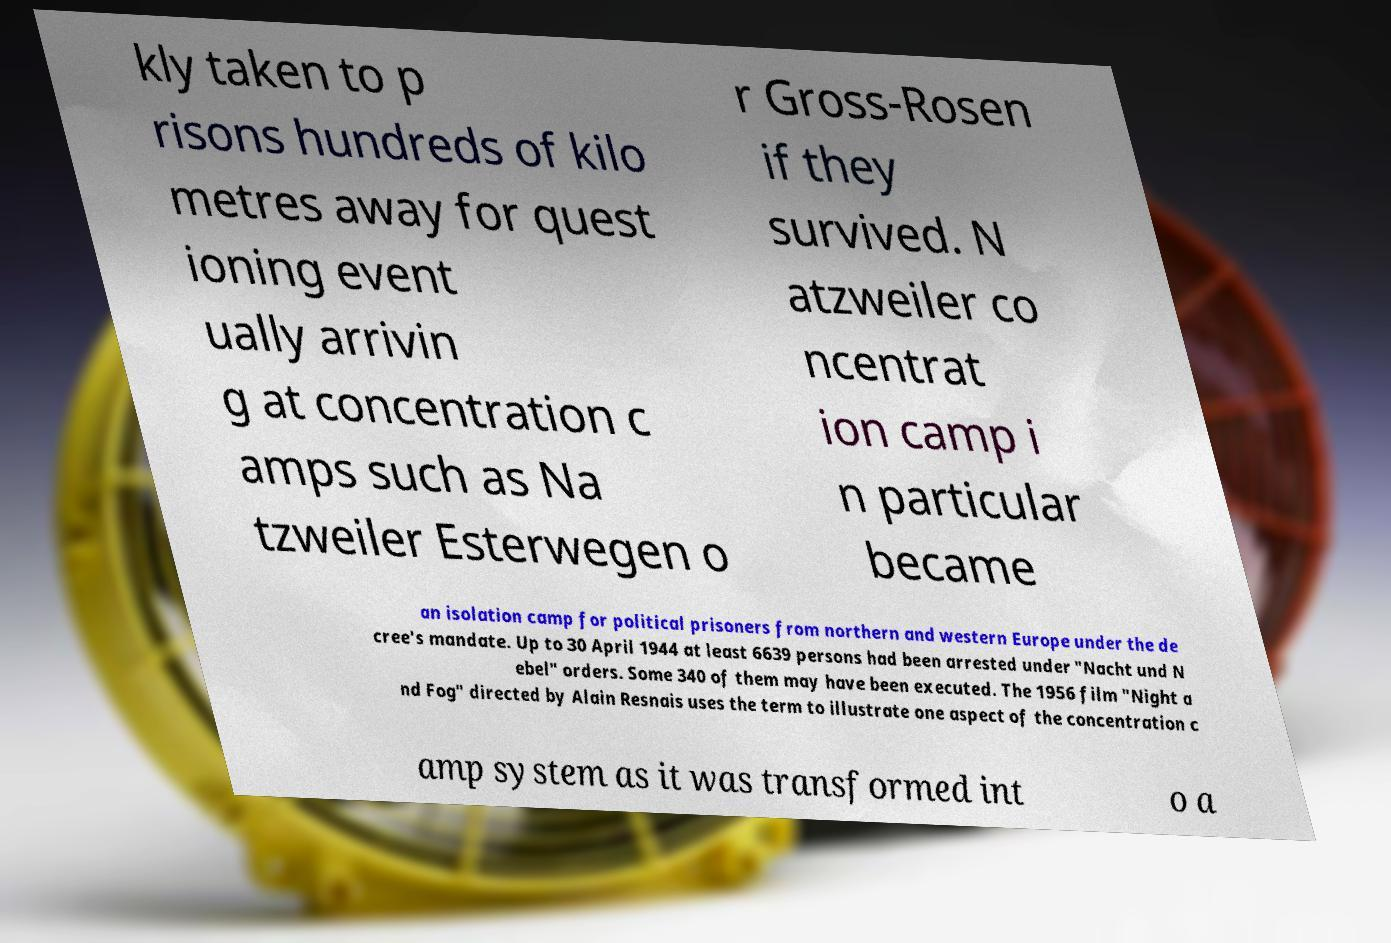I need the written content from this picture converted into text. Can you do that? kly taken to p risons hundreds of kilo metres away for quest ioning event ually arrivin g at concentration c amps such as Na tzweiler Esterwegen o r Gross-Rosen if they survived. N atzweiler co ncentrat ion camp i n particular became an isolation camp for political prisoners from northern and western Europe under the de cree's mandate. Up to 30 April 1944 at least 6639 persons had been arrested under "Nacht und N ebel" orders. Some 340 of them may have been executed. The 1956 film "Night a nd Fog" directed by Alain Resnais uses the term to illustrate one aspect of the concentration c amp system as it was transformed int o a 